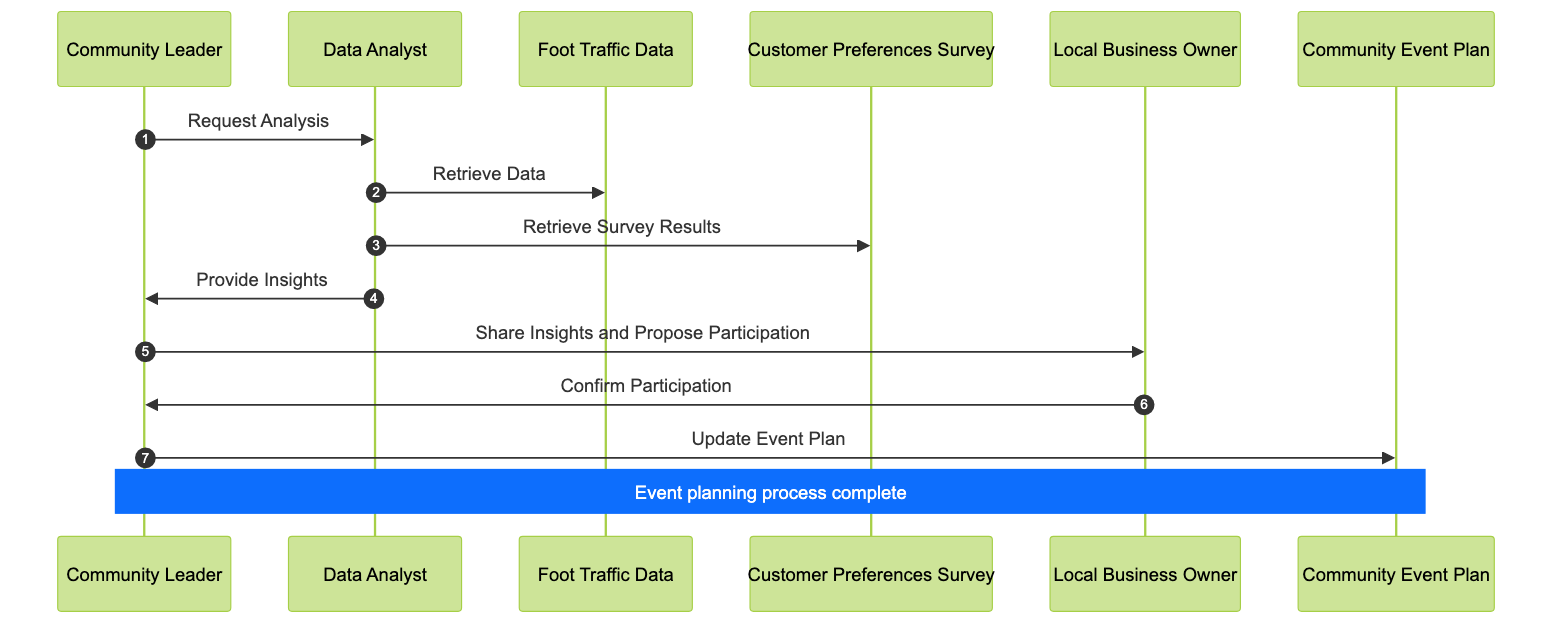What role does the Community Leader have? The Community Leader is described as the "Initiator", which means they are the person who coordinates with local businesses and gathers data on foot traffic and customer preferences.
Answer: Initiator How many messages are exchanged in the diagram? There are six messages exchanged between the actors in the diagram, illustrated by the arrows showing communication flow.
Answer: Six Who confirms participation in the community event? The Local Business Owner is the one who confirms their participation, as indicated by the arrow pointing from them to the Community Leader with the message "Confirm Participation".
Answer: Local Business Owner What is the last action taken in the sequence? The last action in the sequence is the Community Leader updating the event plan, shown by the arrow that connects the Community Leader to the Community Event Plan with the message "Update Event Plan".
Answer: Update Event Plan Which actor retrieves the survey results? The Data Analyst retrieves the survey results, as indicated by the arrow from the Data Analyst to the Customer Preferences Survey with the message "Retrieve Survey Results".
Answer: Data Analyst How does the Community Leader engage with the Local Business Owner? The Community Leader engages by sharing insights and proposing participation in the event, as indicated by the message "Share Insights and Propose Participation" directed towards the Local Business Owner.
Answer: Share Insights and Propose Participation What supports the Community Leader's request? The Data Analyst supports the Community Leader's request by providing insights based on foot traffic data and customer preferences, shown by the message "Provide Insights" directed from Data Analyst to Community Leader.
Answer: Provide Insights What document is updated after confirming participation? The document that is updated is the Community Event Plan, as shown by the arrow from the Community Leader to the Community Event Plan with the message "Update Event Plan".
Answer: Community Event Plan How many participants are involved in the diagram? There are four participants involved in the sequence diagram: Community Leader, Data Analyst, Local Business Owner, and the supporting datasets (Foot Traffic Data, Customer Preferences Survey).
Answer: Four 